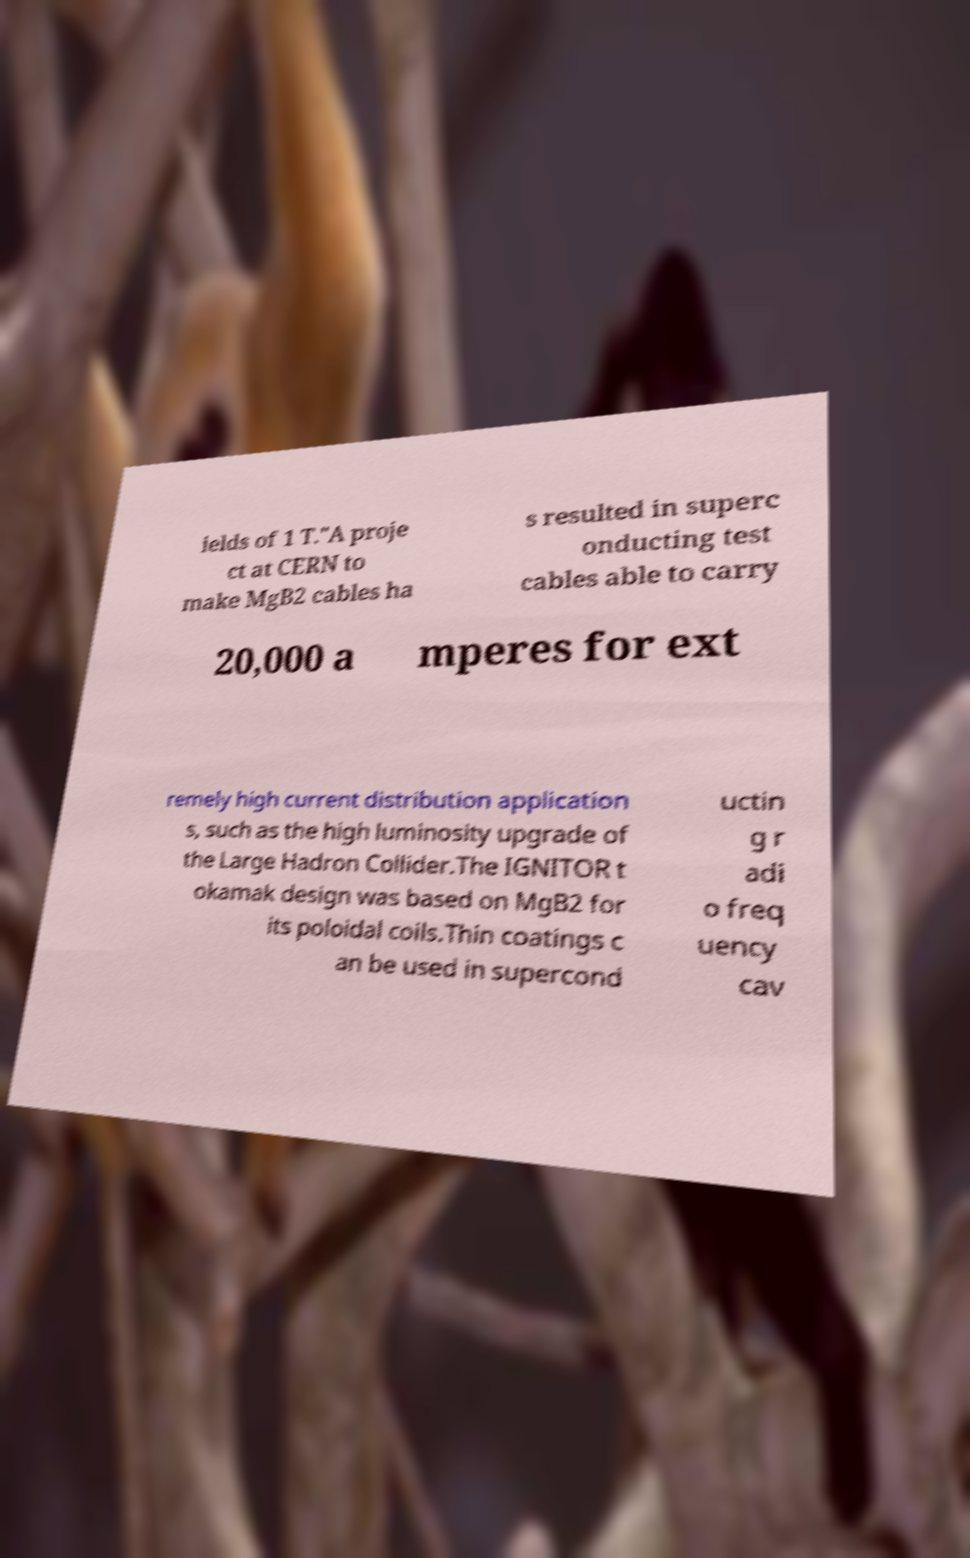Please identify and transcribe the text found in this image. ields of 1 T."A proje ct at CERN to make MgB2 cables ha s resulted in superc onducting test cables able to carry 20,000 a mperes for ext remely high current distribution application s, such as the high luminosity upgrade of the Large Hadron Collider.The IGNITOR t okamak design was based on MgB2 for its poloidal coils.Thin coatings c an be used in supercond uctin g r adi o freq uency cav 